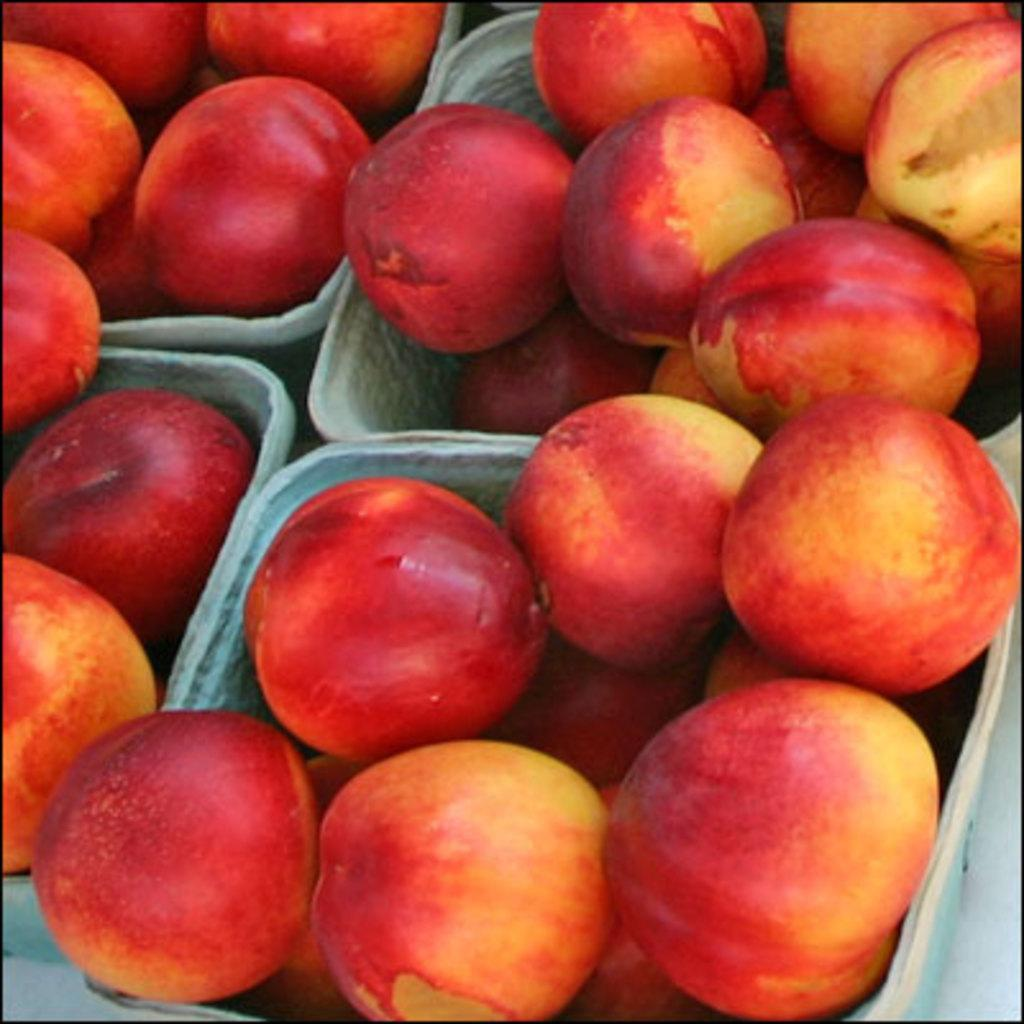What type of food can be seen in the image? There are fruits in the image. How are the fruits arranged or displayed? The fruits are kept in white color bowls. Where are the bowls with fruits located in the image? The bowls are located in the middle of the image. What type of reward is being given to the passenger in the image? There is no passenger or reward present in the image; it features fruits in white color bowls. How many stars can be seen in the image? There are no stars visible in the image. 